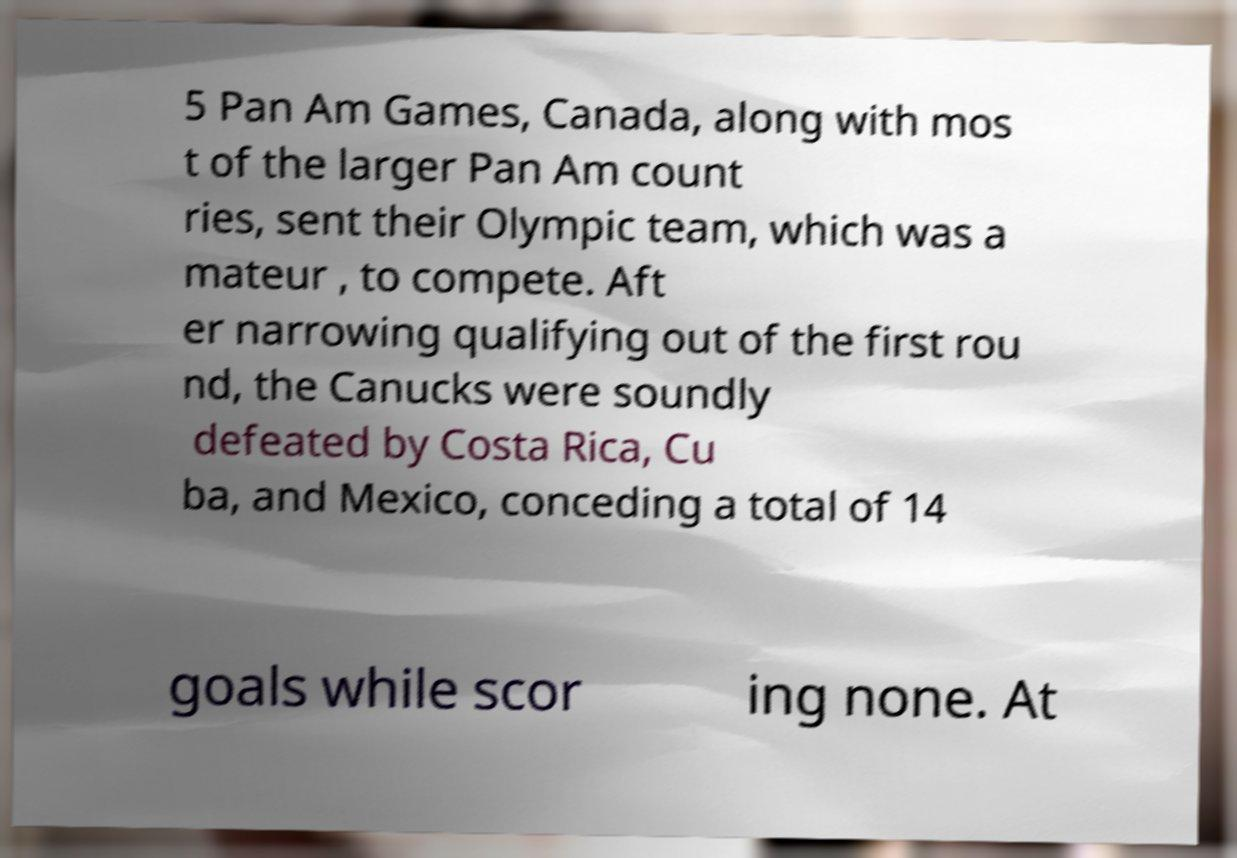There's text embedded in this image that I need extracted. Can you transcribe it verbatim? 5 Pan Am Games, Canada, along with mos t of the larger Pan Am count ries, sent their Olympic team, which was a mateur , to compete. Aft er narrowing qualifying out of the first rou nd, the Canucks were soundly defeated by Costa Rica, Cu ba, and Mexico, conceding a total of 14 goals while scor ing none. At 